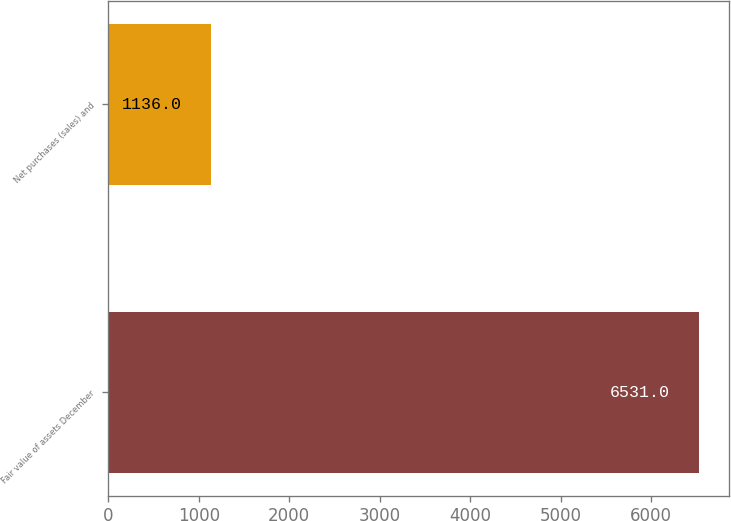<chart> <loc_0><loc_0><loc_500><loc_500><bar_chart><fcel>Fair value of assets December<fcel>Net purchases (sales) and<nl><fcel>6531<fcel>1136<nl></chart> 